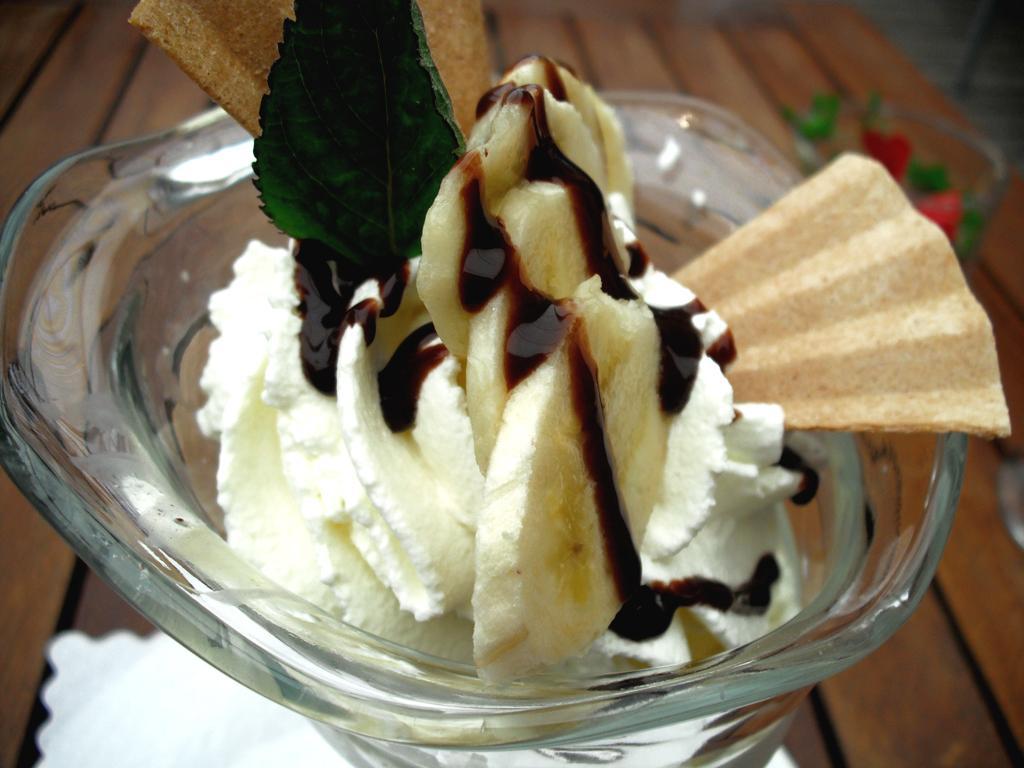Describe this image in one or two sentences. In this picture we can observe an ice cream places in the glass cup. We can observe banana slices and chocolate syrup. There is a green color leaf in the ice cream. This glass cup was placed on the brown color table. We can observe a white color tissue paper on the table. 